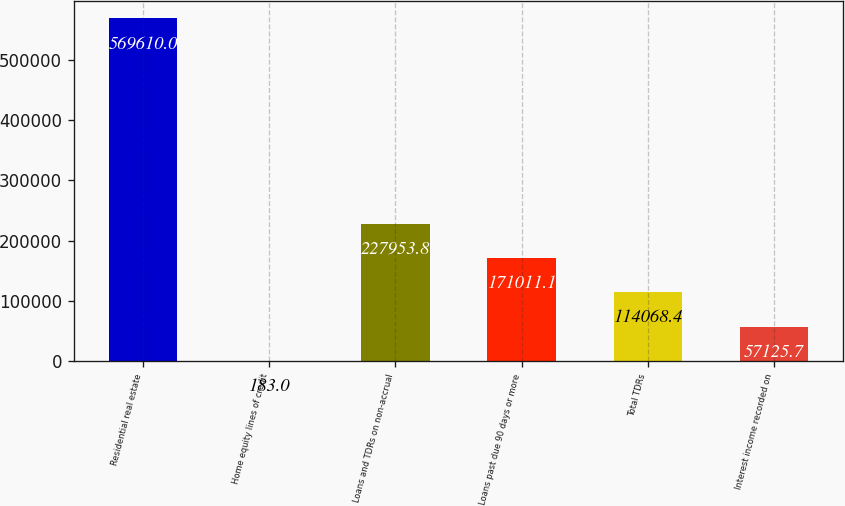Convert chart. <chart><loc_0><loc_0><loc_500><loc_500><bar_chart><fcel>Residential real estate<fcel>Home equity lines of credit<fcel>Loans and TDRs on non-accrual<fcel>Loans past due 90 days or more<fcel>Total TDRs<fcel>Interest income recorded on<nl><fcel>569610<fcel>183<fcel>227954<fcel>171011<fcel>114068<fcel>57125.7<nl></chart> 